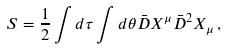<formula> <loc_0><loc_0><loc_500><loc_500>S = \frac { 1 } { 2 } \int d \tau \int d \theta \bar { D } X ^ { \mu } \bar { D } ^ { 2 } X _ { \mu } \, ,</formula> 